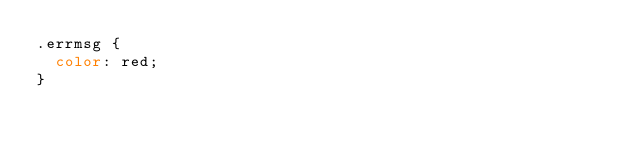Convert code to text. <code><loc_0><loc_0><loc_500><loc_500><_CSS_>.errmsg {
  color: red;
}
</code> 